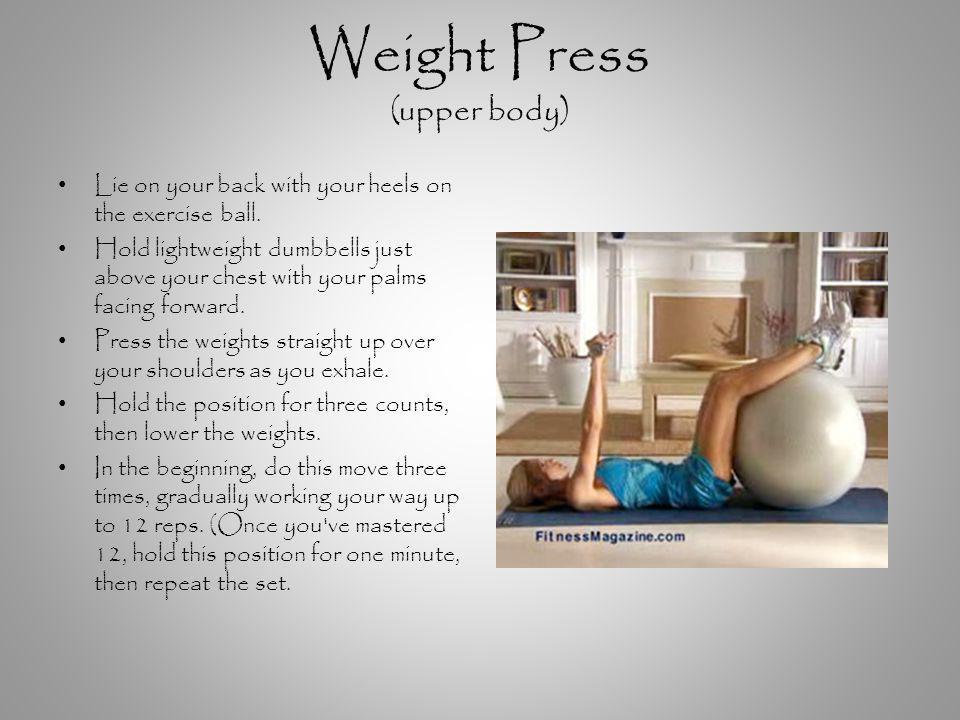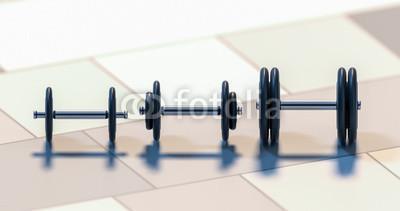The first image is the image on the left, the second image is the image on the right. Evaluate the accuracy of this statement regarding the images: "In one of the images there are three dumbbells of varying sizes arranged in a line.". Is it true? Answer yes or no. Yes. 